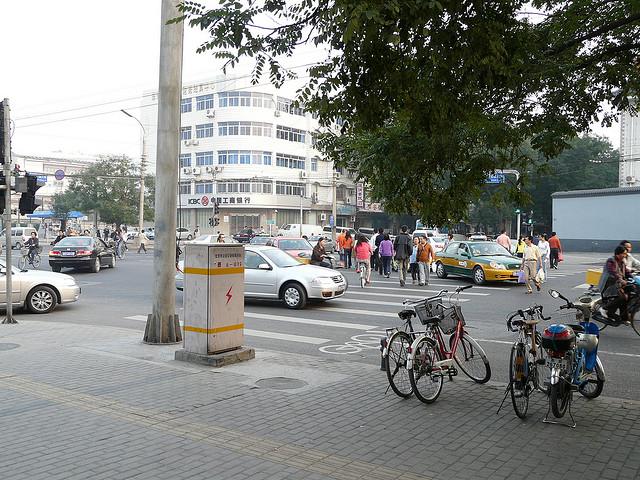How many not motorized vehicles are in the picture?
Concise answer only. 4. Is this an American city?
Write a very short answer. No. Are the bicycles parked too close to the street?
Keep it brief. Yes. 